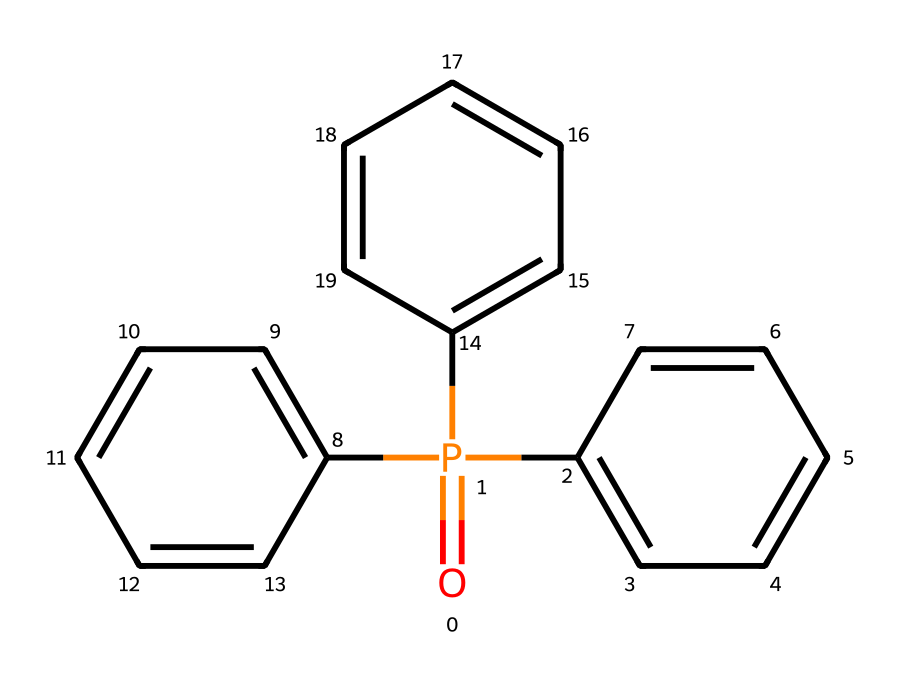What is the molecular formula of triphenyl phosphine oxide? To determine the molecular formula, we count the types and number of atoms in the structure. The phosphorus (P) is present as one atom, the oxygen (O) is one atom, and the three phenyl groups contribute 15 carbon (C) and 15 hydrogen (H) atoms. Therefore, the molecular formula is C18H15O.
Answer: C18H15O How many phenyl rings are present in the structure? The chemical structure displays three distinct phenyl (C6H5) rings linked to the central phosphorus atom. Hence, the count of phenyl rings is three.
Answer: 3 What type of compound is triphenyl phosphine oxide classified as? This compound contains a phosphorus atom bonded to organic groups and has an oxygen atom double-bonded to phosphorus, placing it in the category of organophosphorus compounds.
Answer: organophosphorus What is the hybridization of the phosphorus atom in triphenyl phosphine oxide? The phosphorus atom in this compound is bonded to three phenyl groups and one oxygen atom in a double bond. This leads to a tetrahedral arrangement around phosphorus, resulting in an sp3 hybridization.
Answer: sp3 What type of functional group is present in triphenyl phosphine oxide? The double bond between phosphorus and oxygen indicates the presence of a phosphoryl functional group, which is characteristic of phosphine oxides.
Answer: phosphoryl What is the geometry around the phosphorus atom? The tetrahedral shape arises due to four substituents (three phenyl groups and one double-bonded oxygen) surrounding the phosphorus atom, resulting in a tetrahedral molecular geometry.
Answer: tetrahedral 